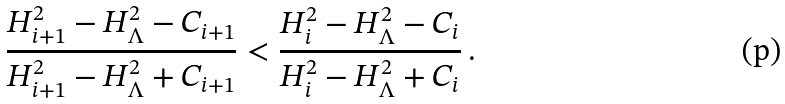Convert formula to latex. <formula><loc_0><loc_0><loc_500><loc_500>\frac { H ^ { 2 } _ { i + 1 } - H ^ { 2 } _ { \Lambda } - C _ { i + 1 } } { H ^ { 2 } _ { i + 1 } - H ^ { 2 } _ { \Lambda } + C _ { i + 1 } } < \frac { H ^ { 2 } _ { i } - H ^ { 2 } _ { \Lambda } - C _ { i } } { H ^ { 2 } _ { i } - H ^ { 2 } _ { \Lambda } + C _ { i } } \, .</formula> 